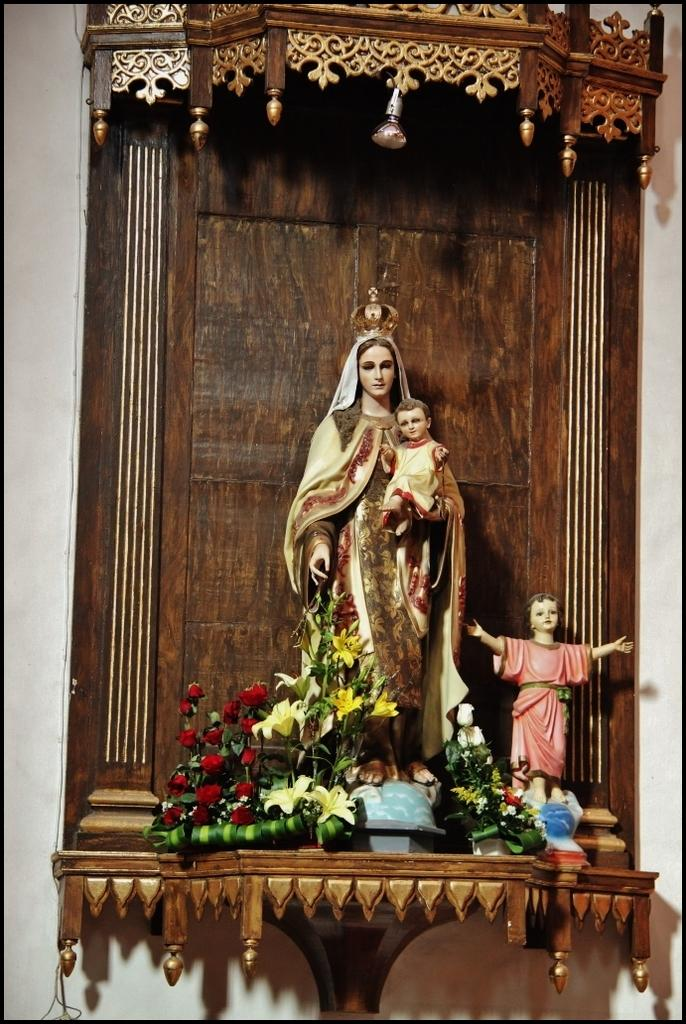What type of objects can be seen in the image? There are statues and flowers in the image. Can you describe the setting of the image? There is a wall in the background of the image. What type of fowl can be seen interacting with the statues in the image? There is no fowl present in the image; it only features statues and flowers. What type of chess pieces are visible on the wall in the image? There are no chess pieces visible on the wall in the image. 